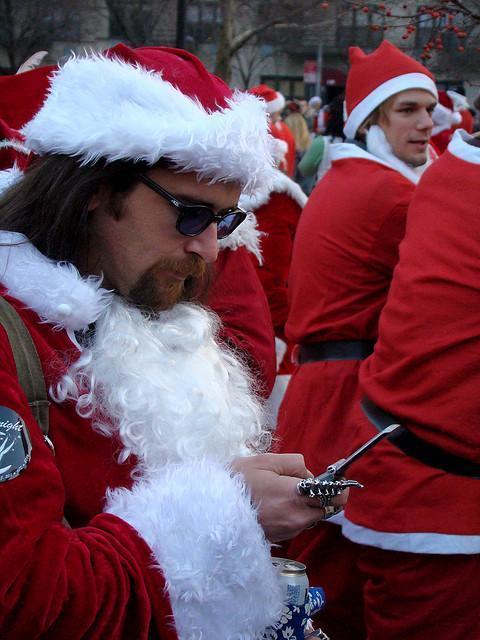What Christmas character are these people all dressed up as?
Select the accurate response from the four choices given to answer the question.
Options: Grinch, santa clause, elves, reindeer. Santa clause. 